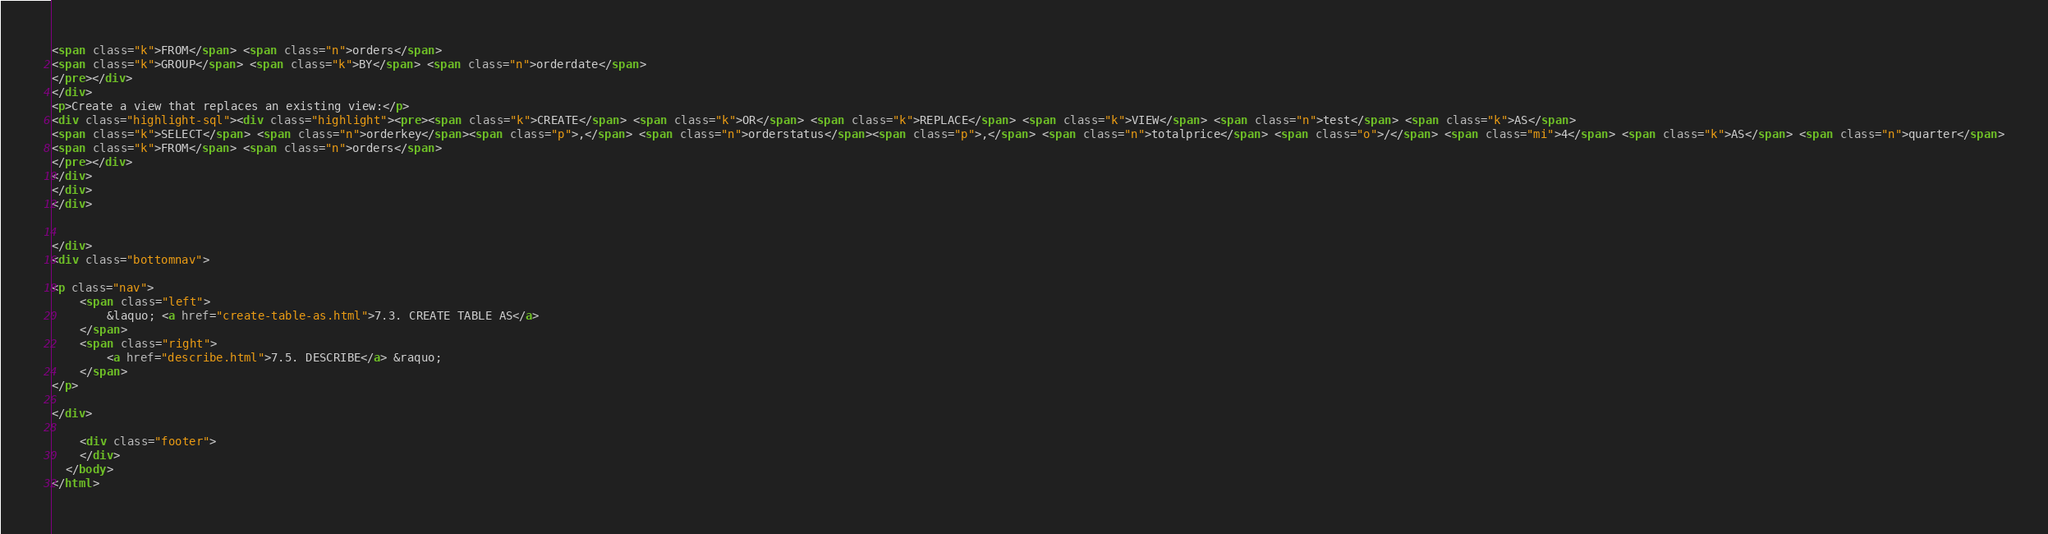Convert code to text. <code><loc_0><loc_0><loc_500><loc_500><_HTML_><span class="k">FROM</span> <span class="n">orders</span>
<span class="k">GROUP</span> <span class="k">BY</span> <span class="n">orderdate</span>
</pre></div>
</div>
<p>Create a view that replaces an existing view:</p>
<div class="highlight-sql"><div class="highlight"><pre><span class="k">CREATE</span> <span class="k">OR</span> <span class="k">REPLACE</span> <span class="k">VIEW</span> <span class="n">test</span> <span class="k">AS</span>
<span class="k">SELECT</span> <span class="n">orderkey</span><span class="p">,</span> <span class="n">orderstatus</span><span class="p">,</span> <span class="n">totalprice</span> <span class="o">/</span> <span class="mi">4</span> <span class="k">AS</span> <span class="n">quarter</span>
<span class="k">FROM</span> <span class="n">orders</span>
</pre></div>
</div>
</div>
</div>


</div>
<div class="bottomnav">
    
<p class="nav">
    <span class="left">
        &laquo; <a href="create-table-as.html">7.3. CREATE TABLE AS</a>
    </span>
    <span class="right">
        <a href="describe.html">7.5. DESCRIBE</a> &raquo;
    </span>
</p>

</div>

    <div class="footer">
    </div>
  </body>
</html></code> 